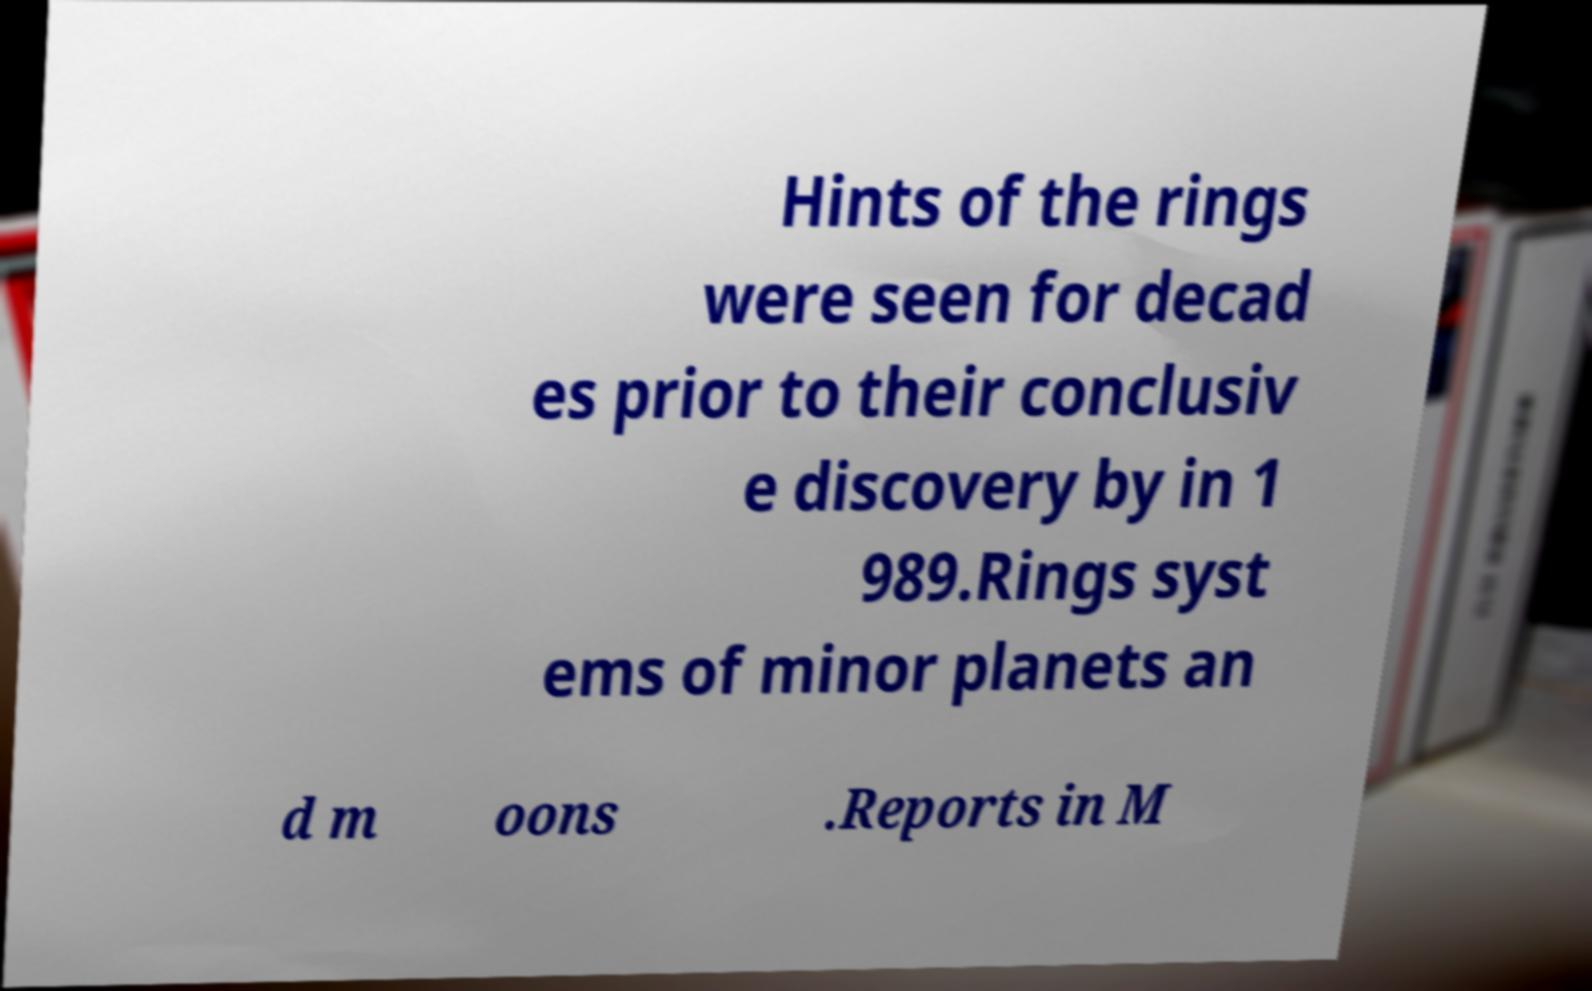Could you assist in decoding the text presented in this image and type it out clearly? Hints of the rings were seen for decad es prior to their conclusiv e discovery by in 1 989.Rings syst ems of minor planets an d m oons .Reports in M 